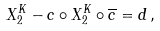Convert formula to latex. <formula><loc_0><loc_0><loc_500><loc_500>X _ { 2 } ^ { K } - c \circ X _ { 2 } ^ { K } \circ \overline { c } = d \, ,</formula> 